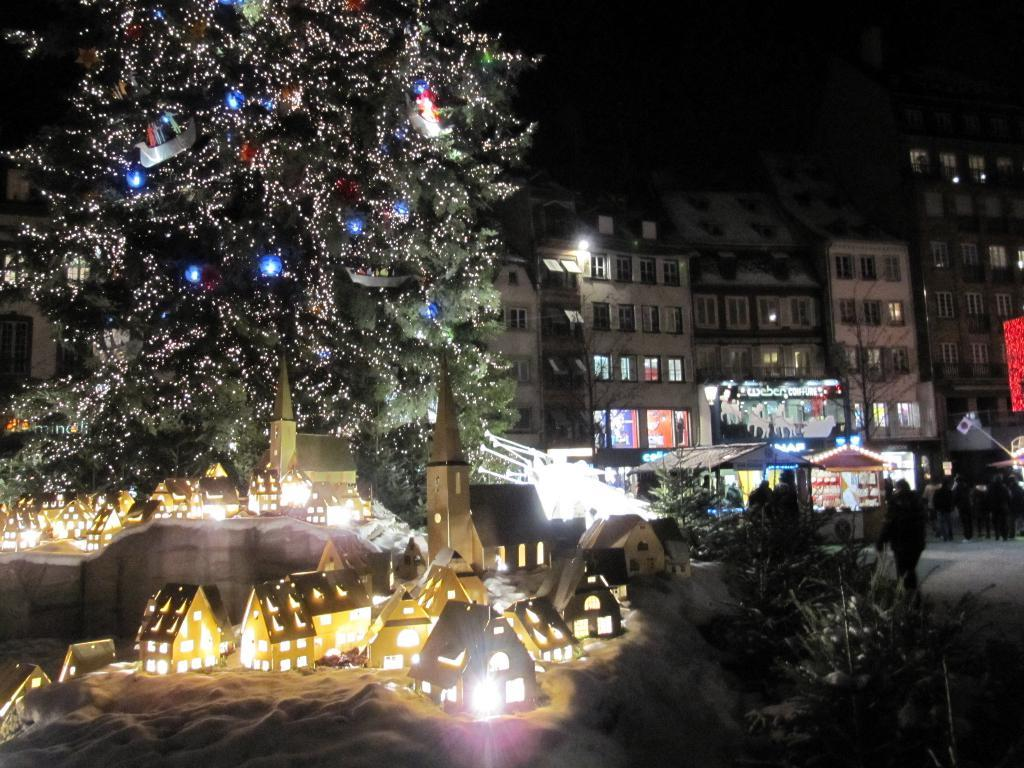What type of structures can be seen in the image? There are buildings in the image. What other natural elements are present in the image? There are trees and plants in the image. Are there any artificial light sources visible in the image? Yes, there are lights in the image. What type of establishment might be represented by the stall in the image? The stall in the image could be a vendor selling food, drinks, or other items. Can you describe the people in the image? There are people in front of the building in the image. What type of conversation is happening at the cemetery in the image? There is no cemetery present in the image; it features buildings, trees, lights, a stall, plants, and people. Can you describe the man standing next to the building in the image? There is no specific mention of a man in the image; it only states that there are people in front of the building. 